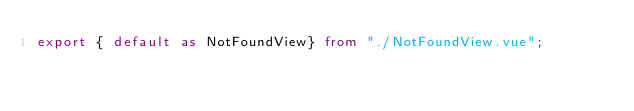<code> <loc_0><loc_0><loc_500><loc_500><_TypeScript_>export { default as NotFoundView} from "./NotFoundView.vue";</code> 